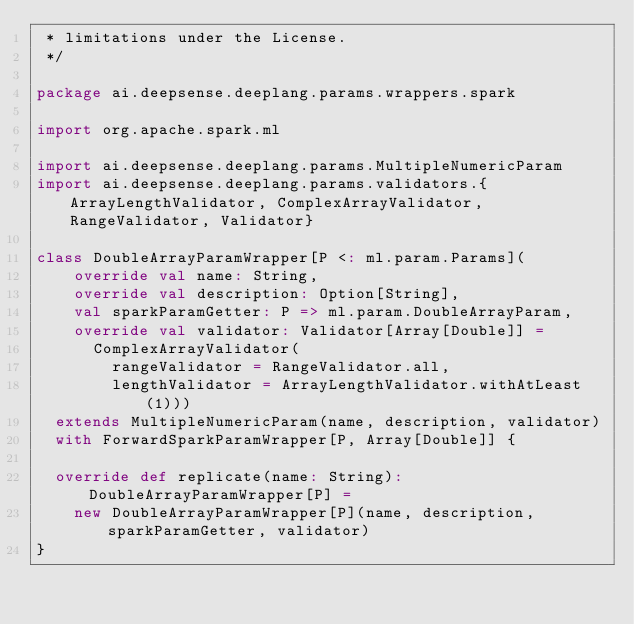<code> <loc_0><loc_0><loc_500><loc_500><_Scala_> * limitations under the License.
 */

package ai.deepsense.deeplang.params.wrappers.spark

import org.apache.spark.ml

import ai.deepsense.deeplang.params.MultipleNumericParam
import ai.deepsense.deeplang.params.validators.{ArrayLengthValidator, ComplexArrayValidator, RangeValidator, Validator}

class DoubleArrayParamWrapper[P <: ml.param.Params](
    override val name: String,
    override val description: Option[String],
    val sparkParamGetter: P => ml.param.DoubleArrayParam,
    override val validator: Validator[Array[Double]] =
      ComplexArrayValidator(
        rangeValidator = RangeValidator.all,
        lengthValidator = ArrayLengthValidator.withAtLeast(1)))
  extends MultipleNumericParam(name, description, validator)
  with ForwardSparkParamWrapper[P, Array[Double]] {

  override def replicate(name: String): DoubleArrayParamWrapper[P] =
    new DoubleArrayParamWrapper[P](name, description, sparkParamGetter, validator)
}
</code> 